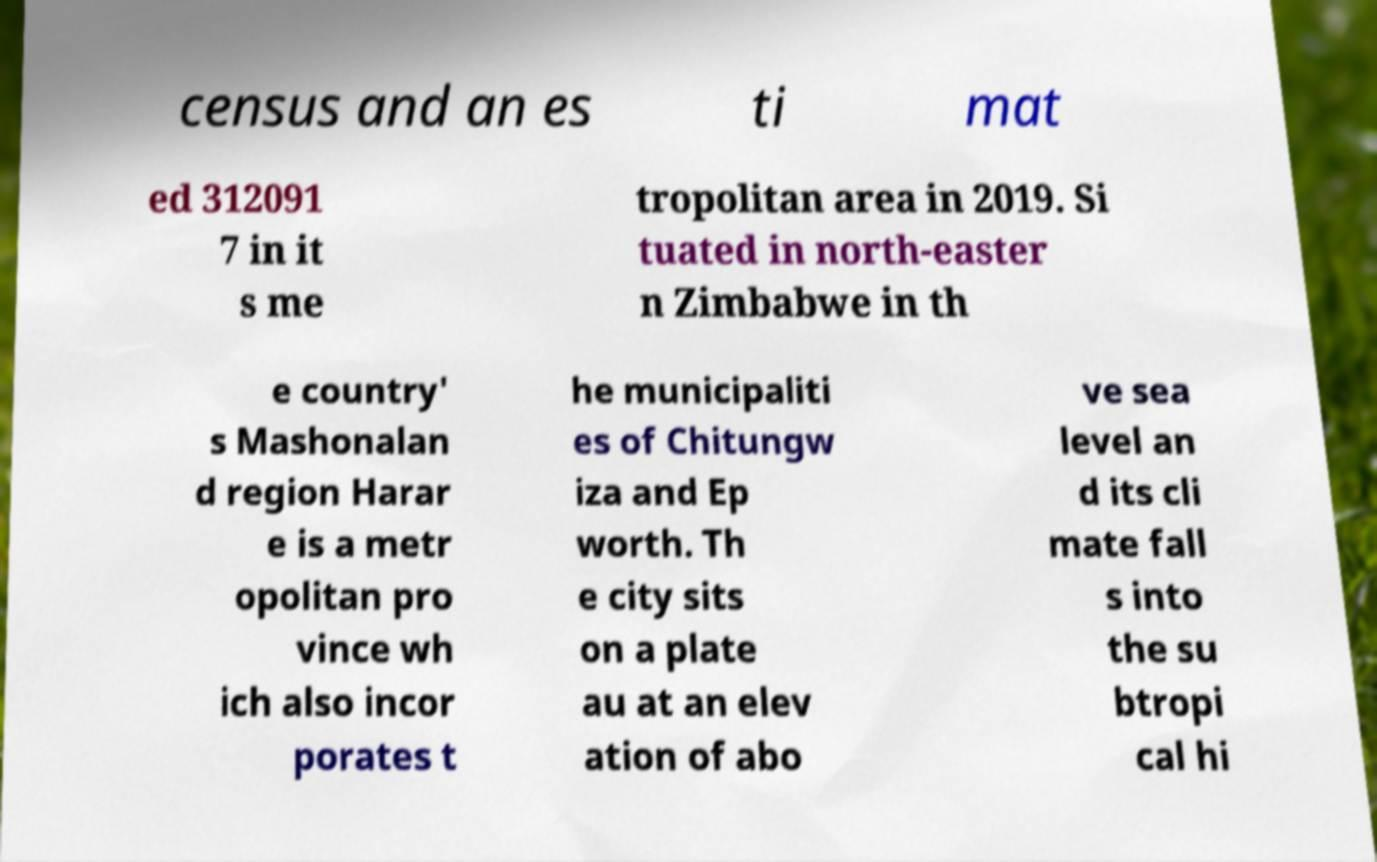What messages or text are displayed in this image? I need them in a readable, typed format. census and an es ti mat ed 312091 7 in it s me tropolitan area in 2019. Si tuated in north-easter n Zimbabwe in th e country' s Mashonalan d region Harar e is a metr opolitan pro vince wh ich also incor porates t he municipaliti es of Chitungw iza and Ep worth. Th e city sits on a plate au at an elev ation of abo ve sea level an d its cli mate fall s into the su btropi cal hi 